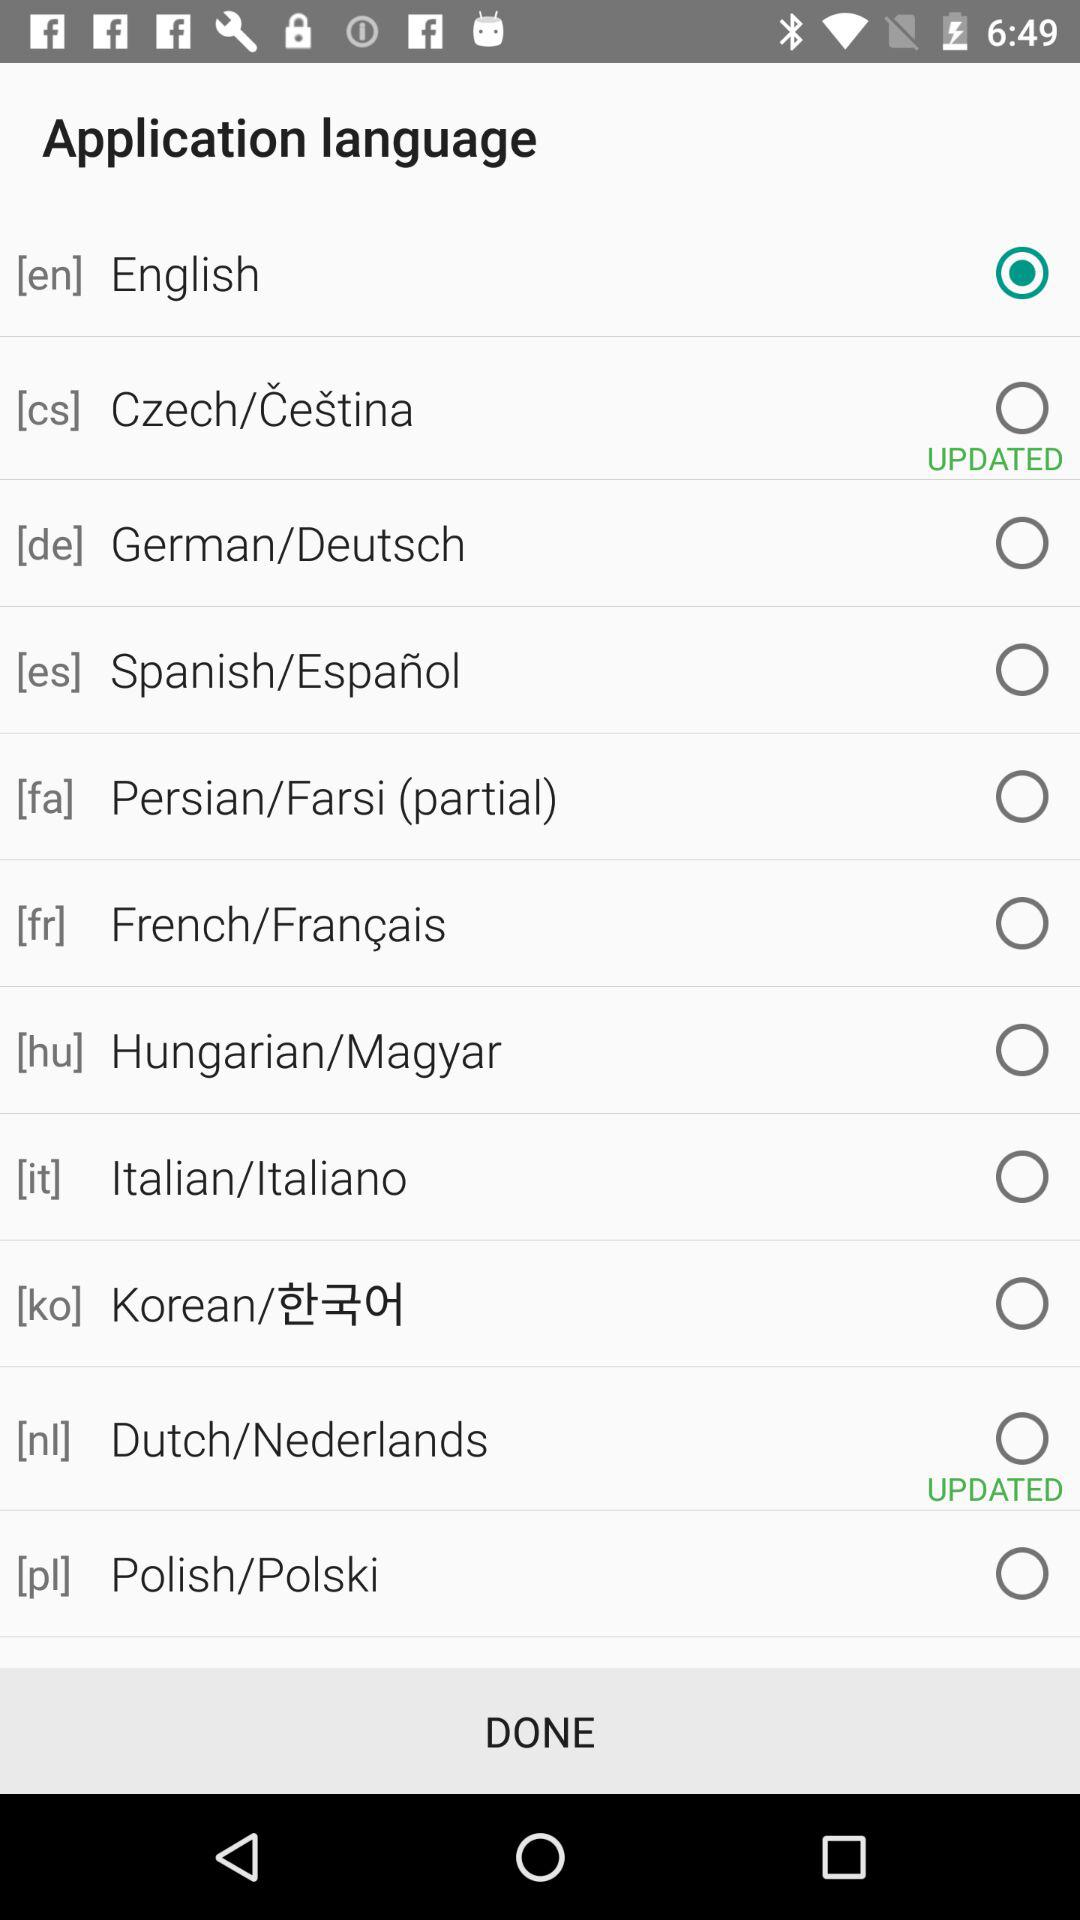Which language is selected currently? The selected language is "English". 